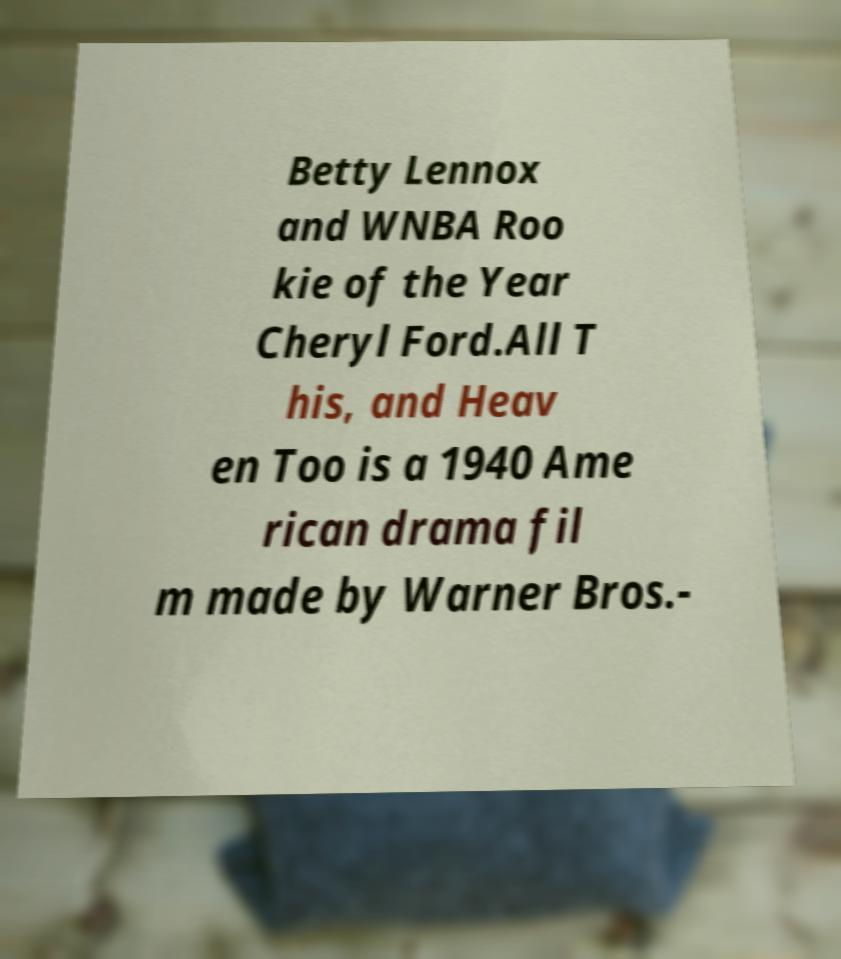Could you extract and type out the text from this image? Betty Lennox and WNBA Roo kie of the Year Cheryl Ford.All T his, and Heav en Too is a 1940 Ame rican drama fil m made by Warner Bros.- 